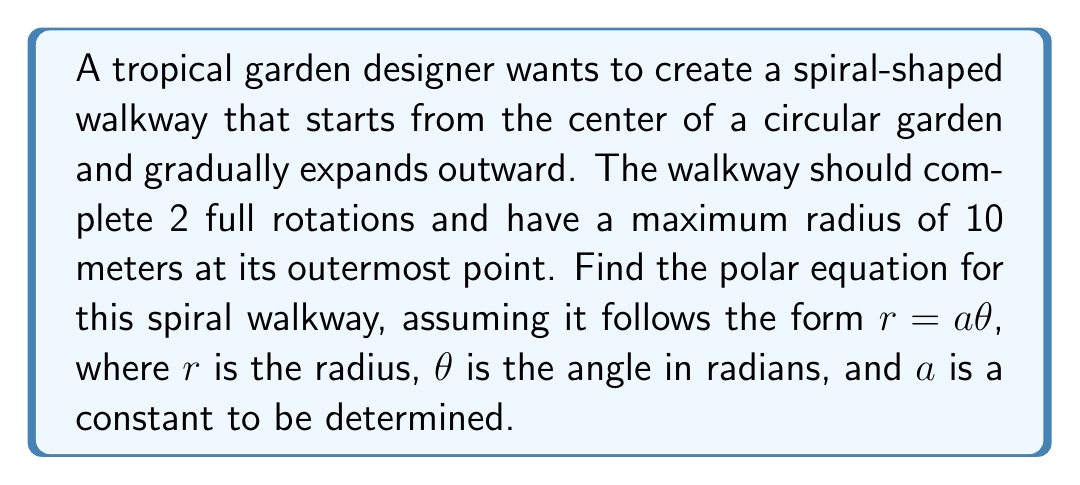Could you help me with this problem? To solve this problem, we need to follow these steps:

1) In a spiral of the form $r = a\theta$, the radius increases linearly with the angle.

2) We know that the spiral makes 2 full rotations. In radians, this is equal to $4\pi$.

3) At the outermost point, we have:
   $r = 10$ (maximum radius)
   $\theta = 4\pi$ (2 full rotations)

4) Substituting these values into the equation $r = a\theta$:

   $$10 = a(4\pi)$$

5) Solving for $a$:

   $$a = \frac{10}{4\pi} = \frac{5}{2\pi}$$

6) Therefore, the polar equation for the spiral walkway is:

   $$r = \frac{5}{2\pi}\theta$$

This equation ensures that when $\theta = 4\pi$ (2 full rotations), $r = 10$ meters, matching our requirements.
Answer: $$r = \frac{5}{2\pi}\theta$$ 